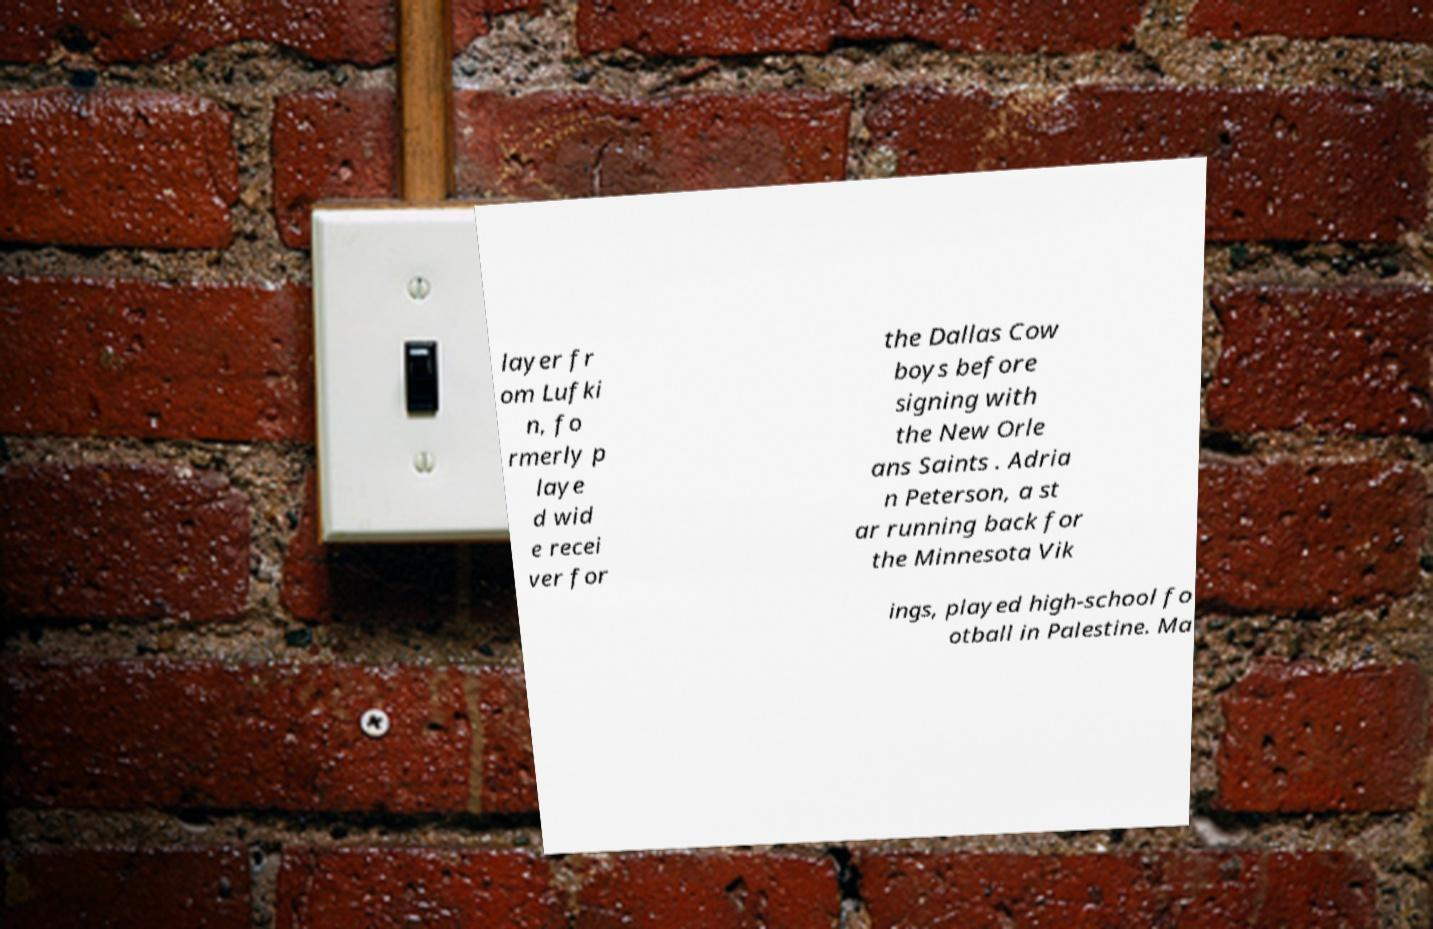There's text embedded in this image that I need extracted. Can you transcribe it verbatim? layer fr om Lufki n, fo rmerly p laye d wid e recei ver for the Dallas Cow boys before signing with the New Orle ans Saints . Adria n Peterson, a st ar running back for the Minnesota Vik ings, played high-school fo otball in Palestine. Ma 